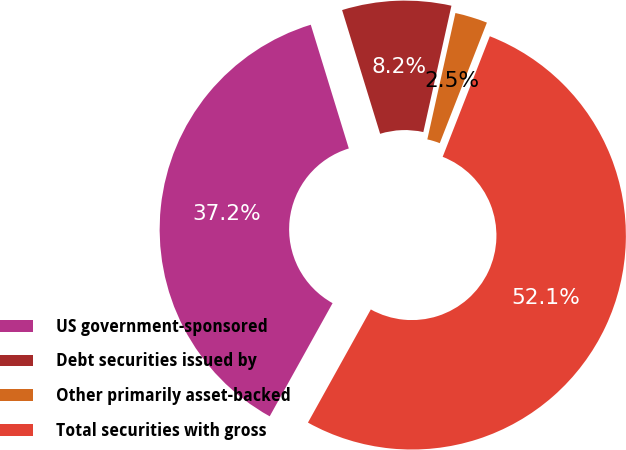<chart> <loc_0><loc_0><loc_500><loc_500><pie_chart><fcel>US government-sponsored<fcel>Debt securities issued by<fcel>Other primarily asset-backed<fcel>Total securities with gross<nl><fcel>37.18%<fcel>8.23%<fcel>2.45%<fcel>52.14%<nl></chart> 